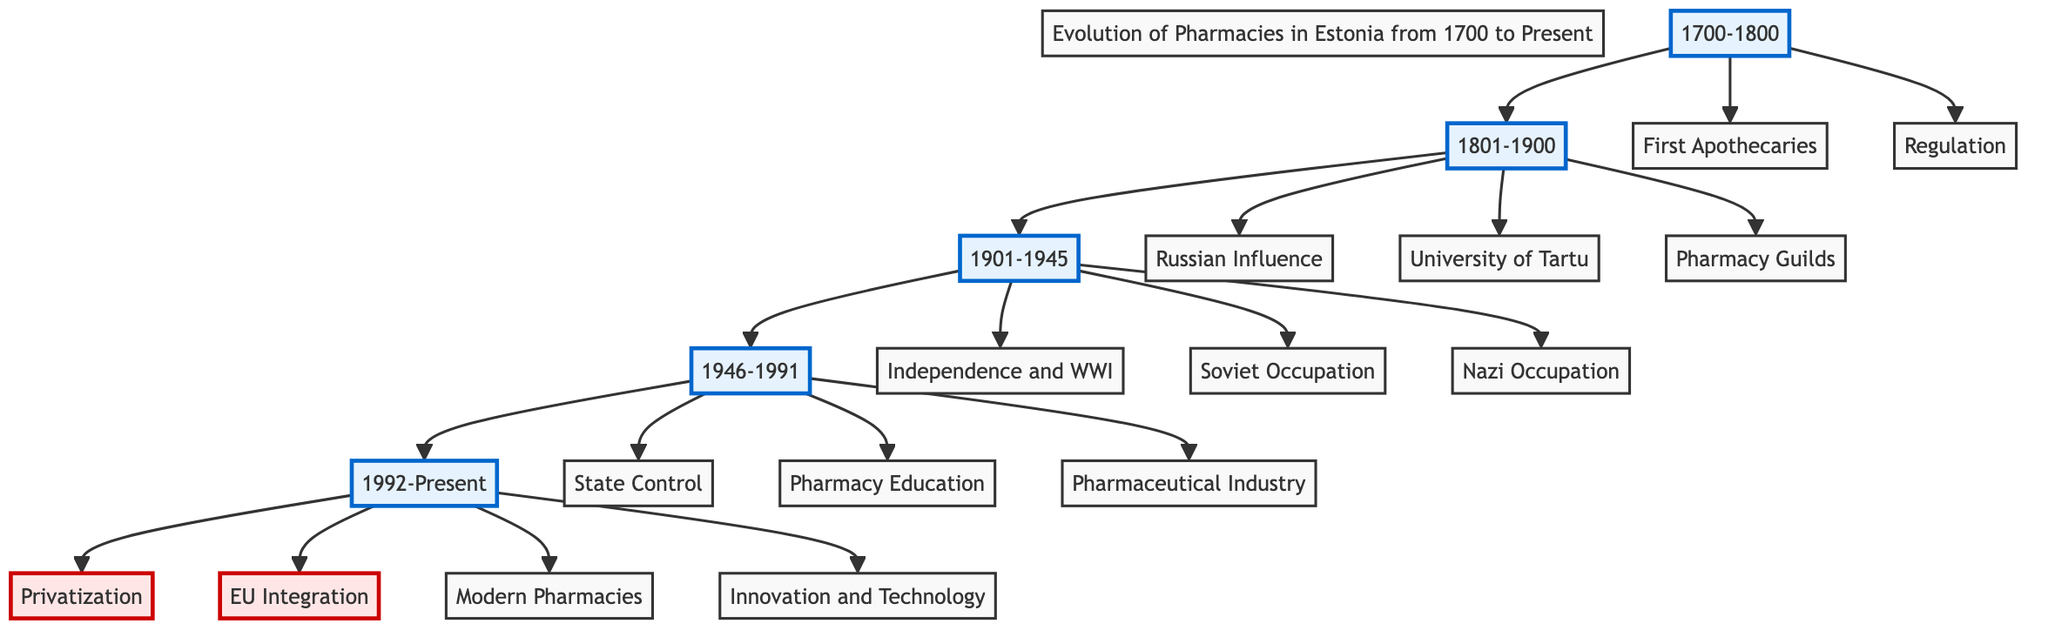What period is marked by the establishment of the first apothecaries? The diagram indicates that the first apothecaries were established during the 1700-1800 period, as represented in block A.
Answer: 1700-1800 How many major eras are depicted in the diagram? The diagram contains five major eras, which are visually represented by five blocks labeled with their respective time periods running from 1700 to Present.
Answer: 5 What was a significant influence on Estonian pharmacies between 1801 and 1900? According to block B, a significant influence on Estonian pharmacies during this time was the Russian Empire's medical practices and regulations.
Answer: Russian Influence What marked the change of pharmacy ownership during 1946-1991? The diagram states that during the era of 1946-1991, the state controlled and centralized pharmacies under Soviet rule, leading to significant changes in ownership and management.
Answer: State Control Which era contains the transition back to privatized pharmacy services? The transition back to privatized pharmacy services occurred in the period from 1992 to Present, as reflected in block E.
Answer: 1992-Present What was introduced during the first period (1700-1800) concerning pharmacy practice? The diagram notes that the first regulations for pharmacy practice were introduced under Swedish rule during the 1700-1800 period.
Answer: Regulation How many key developments are outlined for the 1901-1945 era? The 1901-1945 era includes three key developments, which are shown in block C as the impacts of independence, WWI, Soviet occupation, and Nazi occupation.
Answer: 3 What is the primary change noted in the pharmaceutical industry after 1992? The block labeled "Privatization" represents the primary change noted in the pharmaceutical industry following Estonia's restoration of independence in 1992.
Answer: Privatization Which educational institution played a role in pharmacy development in the 1800s? The University of Tartu was founded during the 1801-1900 period and played a significant role in the development of pharmacy education, as stated in block B.
Answer: University of Tartu 